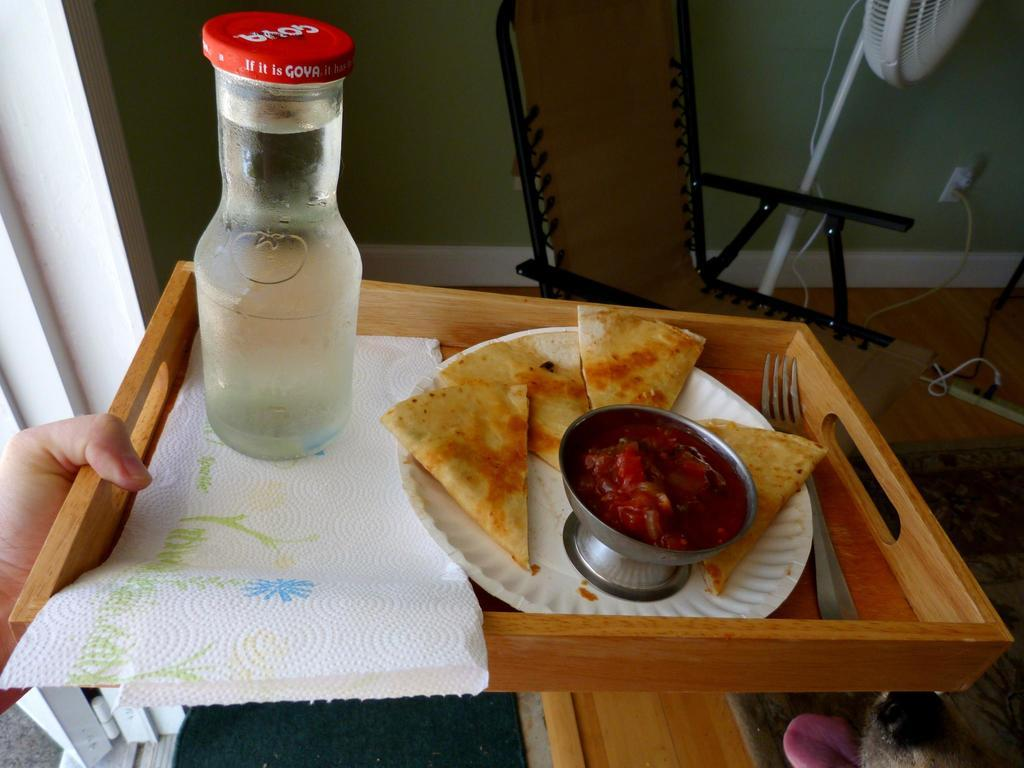What object is being held in the image? A hand is holding a tray in the image. What items can be found on the tray? There is a bottle, tissue paper, a bowl, food, a plate, and a fork on the tray. What is the purpose of the fan in the image? The fan is likely used for cooling or ventilation. What is the chair used for in the image? The chair is likely used for sitting or resting. What can be seen behind the fan in the image? There is a wall visible behind the fan. What authority figure is celebrating their birthday with a glass of milk in the image? There is no authority figure or birthday celebration depicted in the image; it only shows a tray with various items and a fan in the background. 